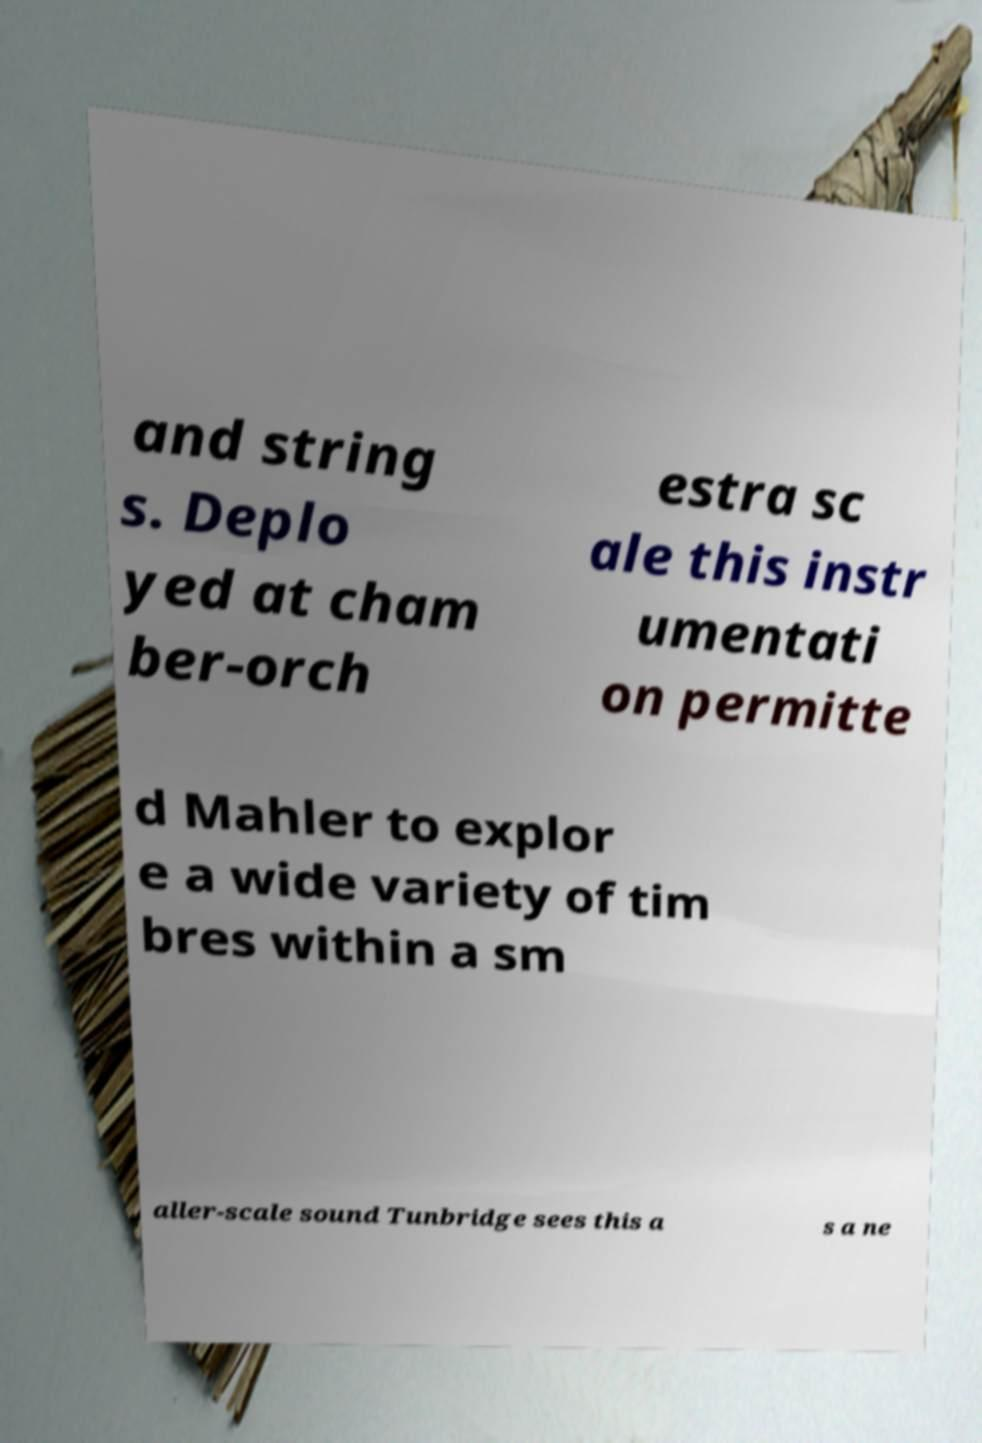There's text embedded in this image that I need extracted. Can you transcribe it verbatim? and string s. Deplo yed at cham ber-orch estra sc ale this instr umentati on permitte d Mahler to explor e a wide variety of tim bres within a sm aller-scale sound Tunbridge sees this a s a ne 